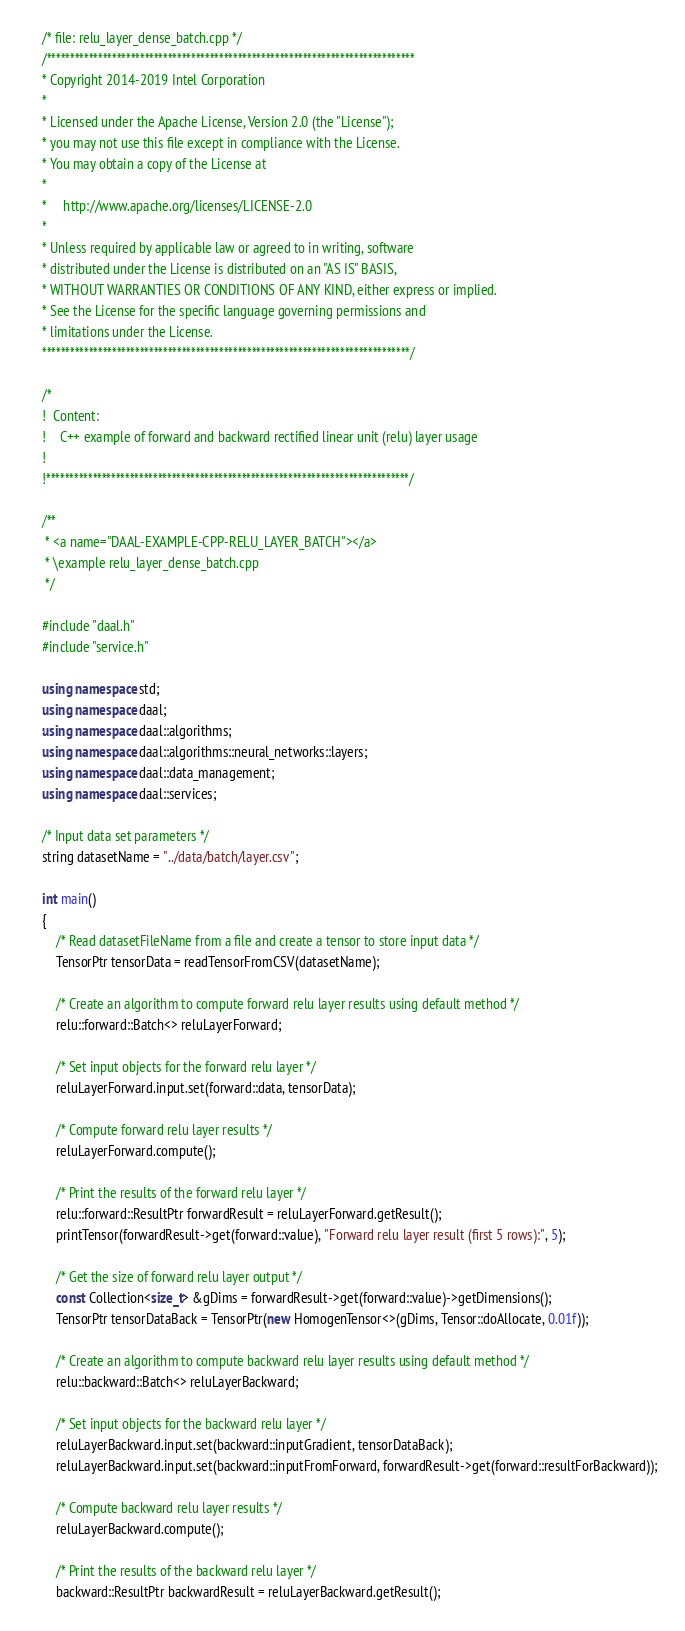Convert code to text. <code><loc_0><loc_0><loc_500><loc_500><_C++_>/* file: relu_layer_dense_batch.cpp */
/*******************************************************************************
* Copyright 2014-2019 Intel Corporation
*
* Licensed under the Apache License, Version 2.0 (the "License");
* you may not use this file except in compliance with the License.
* You may obtain a copy of the License at
*
*     http://www.apache.org/licenses/LICENSE-2.0
*
* Unless required by applicable law or agreed to in writing, software
* distributed under the License is distributed on an "AS IS" BASIS,
* WITHOUT WARRANTIES OR CONDITIONS OF ANY KIND, either express or implied.
* See the License for the specific language governing permissions and
* limitations under the License.
*******************************************************************************/

/*
!  Content:
!    C++ example of forward and backward rectified linear unit (relu) layer usage
!
!******************************************************************************/

/**
 * <a name="DAAL-EXAMPLE-CPP-RELU_LAYER_BATCH"></a>
 * \example relu_layer_dense_batch.cpp
 */

#include "daal.h"
#include "service.h"

using namespace std;
using namespace daal;
using namespace daal::algorithms;
using namespace daal::algorithms::neural_networks::layers;
using namespace daal::data_management;
using namespace daal::services;

/* Input data set parameters */
string datasetName = "../data/batch/layer.csv";

int main()
{
    /* Read datasetFileName from a file and create a tensor to store input data */
    TensorPtr tensorData = readTensorFromCSV(datasetName);

    /* Create an algorithm to compute forward relu layer results using default method */
    relu::forward::Batch<> reluLayerForward;

    /* Set input objects for the forward relu layer */
    reluLayerForward.input.set(forward::data, tensorData);

    /* Compute forward relu layer results */
    reluLayerForward.compute();

    /* Print the results of the forward relu layer */
    relu::forward::ResultPtr forwardResult = reluLayerForward.getResult();
    printTensor(forwardResult->get(forward::value), "Forward relu layer result (first 5 rows):", 5);

    /* Get the size of forward relu layer output */
    const Collection<size_t> &gDims = forwardResult->get(forward::value)->getDimensions();
    TensorPtr tensorDataBack = TensorPtr(new HomogenTensor<>(gDims, Tensor::doAllocate, 0.01f));

    /* Create an algorithm to compute backward relu layer results using default method */
    relu::backward::Batch<> reluLayerBackward;

    /* Set input objects for the backward relu layer */
    reluLayerBackward.input.set(backward::inputGradient, tensorDataBack);
    reluLayerBackward.input.set(backward::inputFromForward, forwardResult->get(forward::resultForBackward));

    /* Compute backward relu layer results */
    reluLayerBackward.compute();

    /* Print the results of the backward relu layer */
    backward::ResultPtr backwardResult = reluLayerBackward.getResult();</code> 